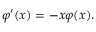Convert formula to latex. <formula><loc_0><loc_0><loc_500><loc_500>\varphi ^ { \prime } ( x ) = - x \varphi ( x ) .</formula> 